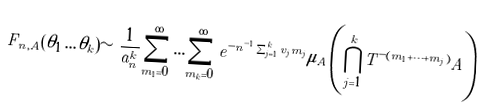Convert formula to latex. <formula><loc_0><loc_0><loc_500><loc_500>F _ { n , A } ( \theta _ { 1 } \dots \theta _ { k } ) \sim \frac { 1 } { a _ { n } ^ { k } } \sum _ { m _ { 1 } = 0 } ^ { \infty } \dots \sum _ { m _ { k } = 0 } ^ { \infty } e ^ { - n ^ { - 1 } \sum _ { j = 1 } ^ { k } v _ { j } m _ { j } } \mu _ { A } \left ( \bigcap _ { j = 1 } ^ { k } T ^ { - ( m _ { 1 } + \dots + m _ { j } ) } A \right )</formula> 